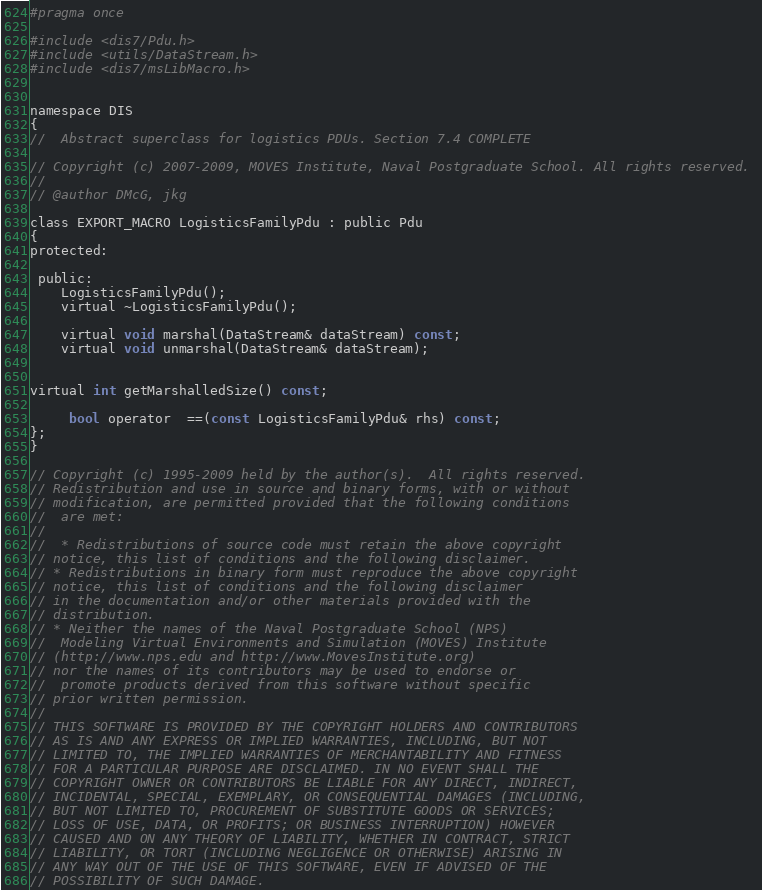Convert code to text. <code><loc_0><loc_0><loc_500><loc_500><_C_>#pragma once

#include <dis7/Pdu.h>
#include <utils/DataStream.h>
#include <dis7/msLibMacro.h>


namespace DIS
{
//  Abstract superclass for logistics PDUs. Section 7.4 COMPLETE

// Copyright (c) 2007-2009, MOVES Institute, Naval Postgraduate School. All rights reserved. 
//
// @author DMcG, jkg

class EXPORT_MACRO LogisticsFamilyPdu : public Pdu
{
protected:

 public:
    LogisticsFamilyPdu();
    virtual ~LogisticsFamilyPdu();

    virtual void marshal(DataStream& dataStream) const;
    virtual void unmarshal(DataStream& dataStream);


virtual int getMarshalledSize() const;

     bool operator  ==(const LogisticsFamilyPdu& rhs) const;
};
}

// Copyright (c) 1995-2009 held by the author(s).  All rights reserved.
// Redistribution and use in source and binary forms, with or without
// modification, are permitted provided that the following conditions
//  are met:
// 
//  * Redistributions of source code must retain the above copyright
// notice, this list of conditions and the following disclaimer.
// * Redistributions in binary form must reproduce the above copyright
// notice, this list of conditions and the following disclaimer
// in the documentation and/or other materials provided with the
// distribution.
// * Neither the names of the Naval Postgraduate School (NPS)
//  Modeling Virtual Environments and Simulation (MOVES) Institute
// (http://www.nps.edu and http://www.MovesInstitute.org)
// nor the names of its contributors may be used to endorse or
//  promote products derived from this software without specific
// prior written permission.
// 
// THIS SOFTWARE IS PROVIDED BY THE COPYRIGHT HOLDERS AND CONTRIBUTORS
// AS IS AND ANY EXPRESS OR IMPLIED WARRANTIES, INCLUDING, BUT NOT
// LIMITED TO, THE IMPLIED WARRANTIES OF MERCHANTABILITY AND FITNESS
// FOR A PARTICULAR PURPOSE ARE DISCLAIMED. IN NO EVENT SHALL THE
// COPYRIGHT OWNER OR CONTRIBUTORS BE LIABLE FOR ANY DIRECT, INDIRECT,
// INCIDENTAL, SPECIAL, EXEMPLARY, OR CONSEQUENTIAL DAMAGES (INCLUDING,
// BUT NOT LIMITED TO, PROCUREMENT OF SUBSTITUTE GOODS OR SERVICES;
// LOSS OF USE, DATA, OR PROFITS; OR BUSINESS INTERRUPTION) HOWEVER
// CAUSED AND ON ANY THEORY OF LIABILITY, WHETHER IN CONTRACT, STRICT
// LIABILITY, OR TORT (INCLUDING NEGLIGENCE OR OTHERWISE) ARISING IN
// ANY WAY OUT OF THE USE OF THIS SOFTWARE, EVEN IF ADVISED OF THE
// POSSIBILITY OF SUCH DAMAGE.
</code> 